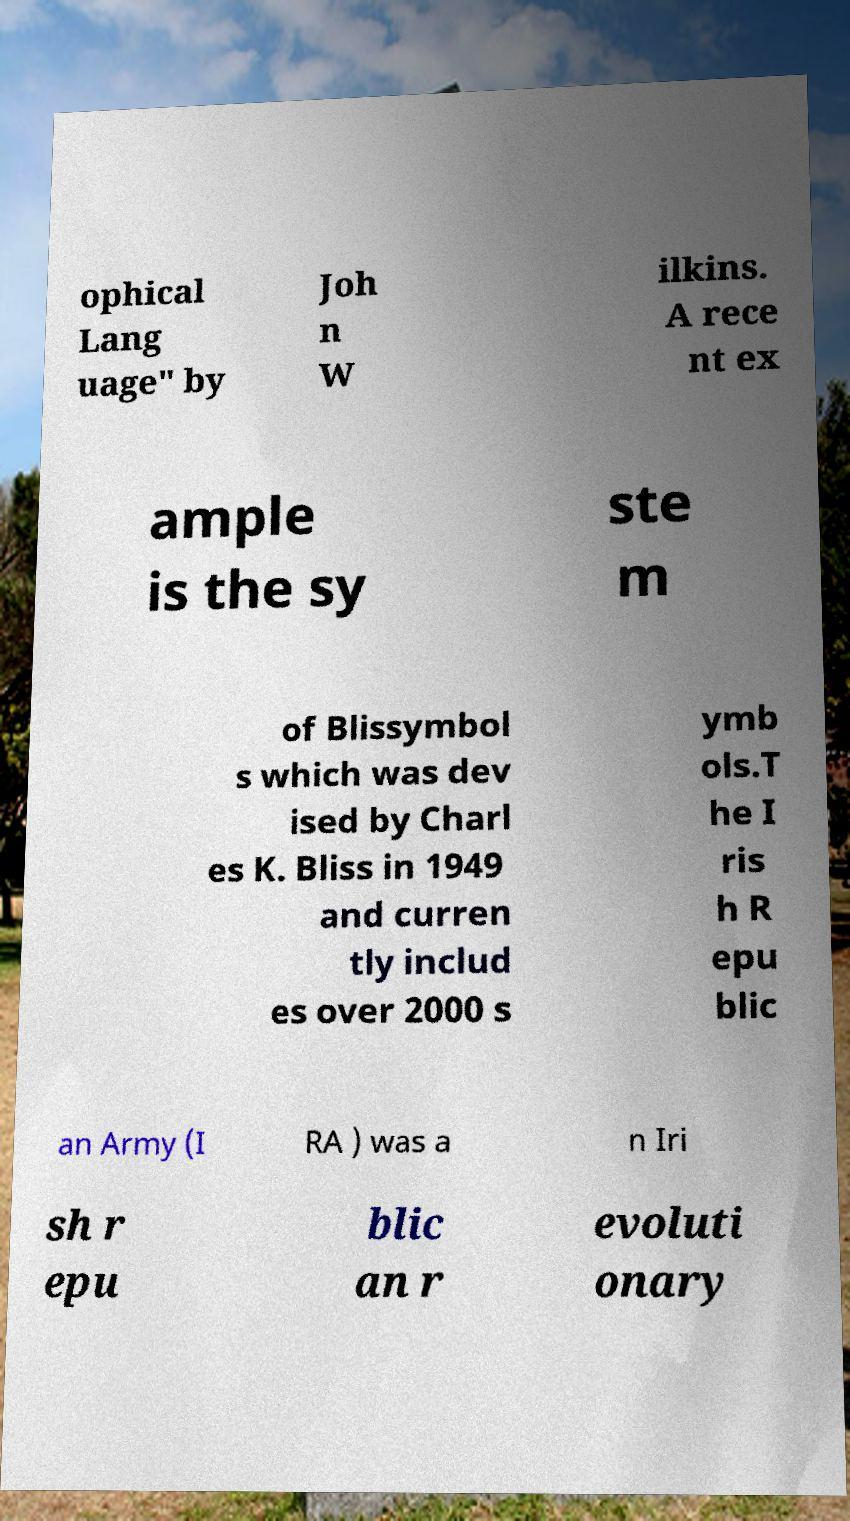For documentation purposes, I need the text within this image transcribed. Could you provide that? ophical Lang uage" by Joh n W ilkins. A rece nt ex ample is the sy ste m of Blissymbol s which was dev ised by Charl es K. Bliss in 1949 and curren tly includ es over 2000 s ymb ols.T he I ris h R epu blic an Army (I RA ) was a n Iri sh r epu blic an r evoluti onary 